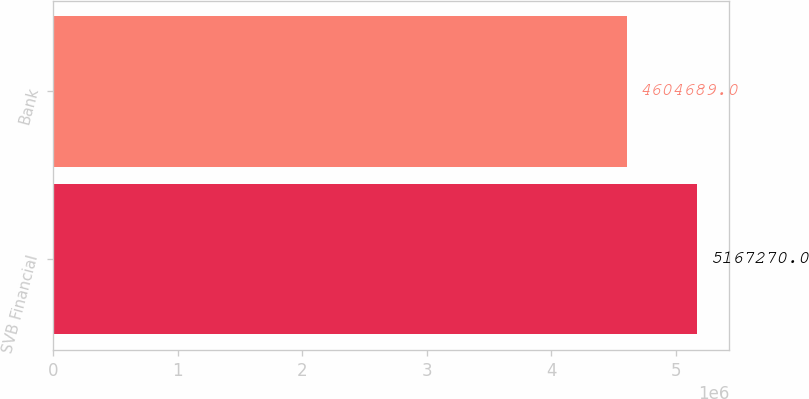<chart> <loc_0><loc_0><loc_500><loc_500><bar_chart><fcel>SVB Financial<fcel>Bank<nl><fcel>5.16727e+06<fcel>4.60469e+06<nl></chart> 